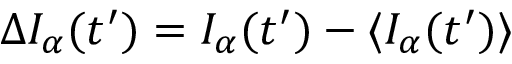<formula> <loc_0><loc_0><loc_500><loc_500>\Delta I _ { \alpha } ( t ^ { \prime } ) = I _ { \alpha } ( t ^ { \prime } ) - \langle I _ { \alpha } ( t ^ { \prime } ) \rangle</formula> 